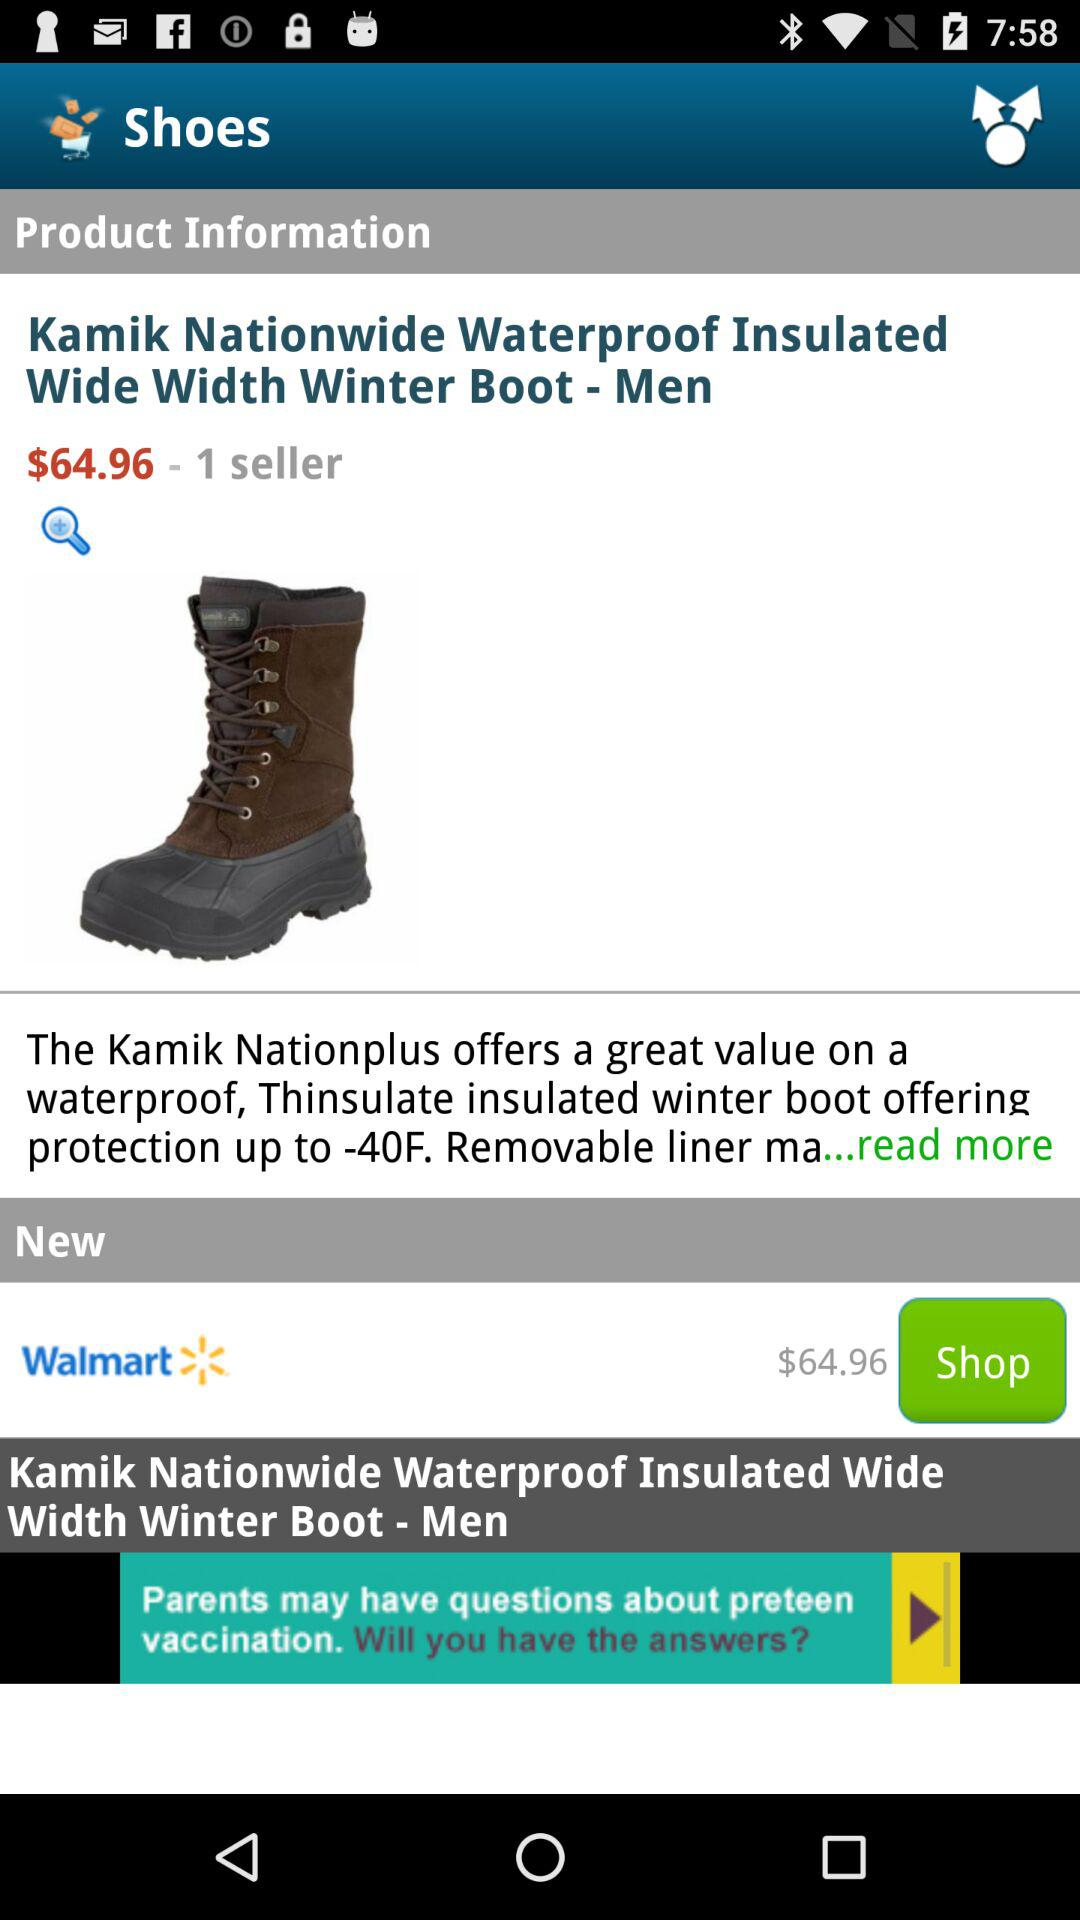What is the name of the product? The name of the product is "Kamik Nationwide Waterproof Insulated Wide Width Winter Boot - Men". 